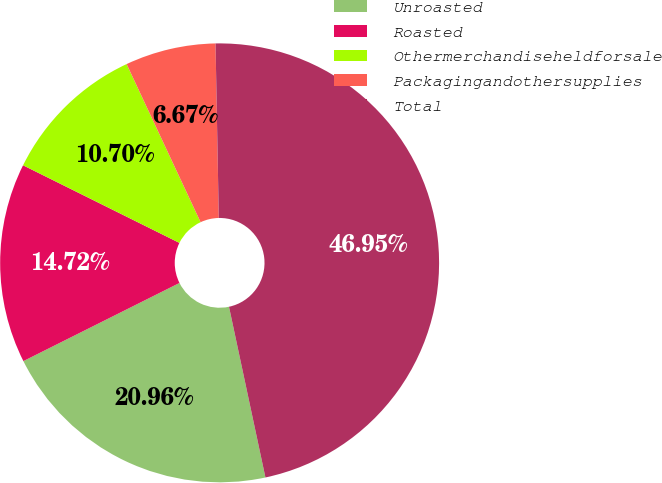<chart> <loc_0><loc_0><loc_500><loc_500><pie_chart><fcel>Unroasted<fcel>Roasted<fcel>Othermerchandiseheldforsale<fcel>Packagingandothersupplies<fcel>Total<nl><fcel>20.96%<fcel>14.72%<fcel>10.7%<fcel>6.67%<fcel>46.95%<nl></chart> 